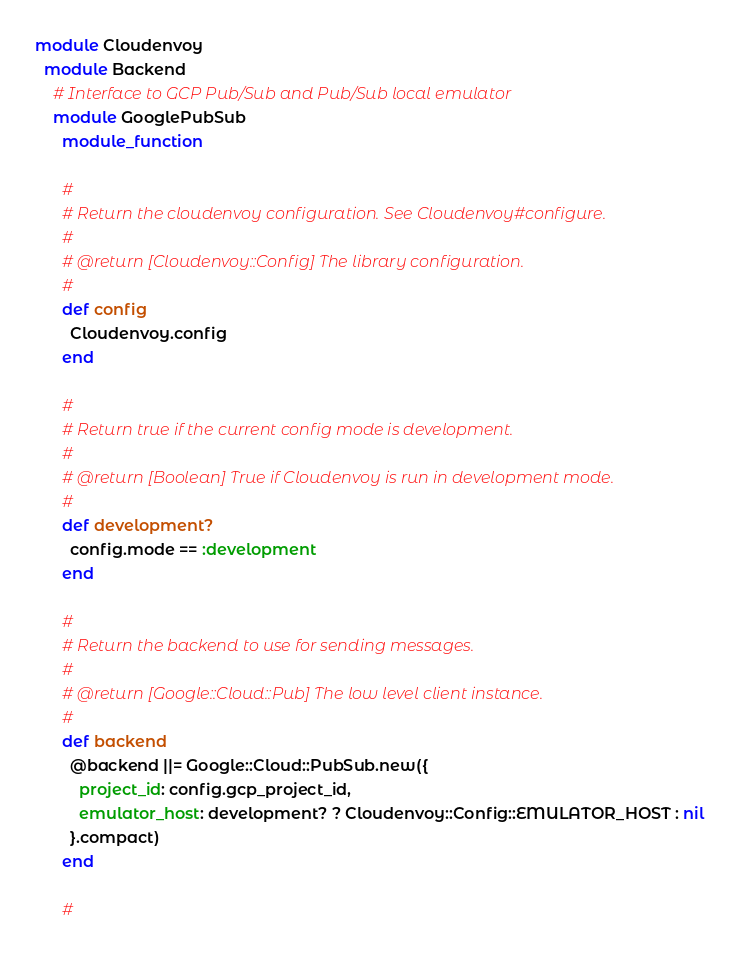<code> <loc_0><loc_0><loc_500><loc_500><_Ruby_>
module Cloudenvoy
  module Backend
    # Interface to GCP Pub/Sub and Pub/Sub local emulator
    module GooglePubSub
      module_function

      #
      # Return the cloudenvoy configuration. See Cloudenvoy#configure.
      #
      # @return [Cloudenvoy::Config] The library configuration.
      #
      def config
        Cloudenvoy.config
      end

      #
      # Return true if the current config mode is development.
      #
      # @return [Boolean] True if Cloudenvoy is run in development mode.
      #
      def development?
        config.mode == :development
      end

      #
      # Return the backend to use for sending messages.
      #
      # @return [Google::Cloud::Pub] The low level client instance.
      #
      def backend
        @backend ||= Google::Cloud::PubSub.new({
          project_id: config.gcp_project_id,
          emulator_host: development? ? Cloudenvoy::Config::EMULATOR_HOST : nil
        }.compact)
      end

      #</code> 